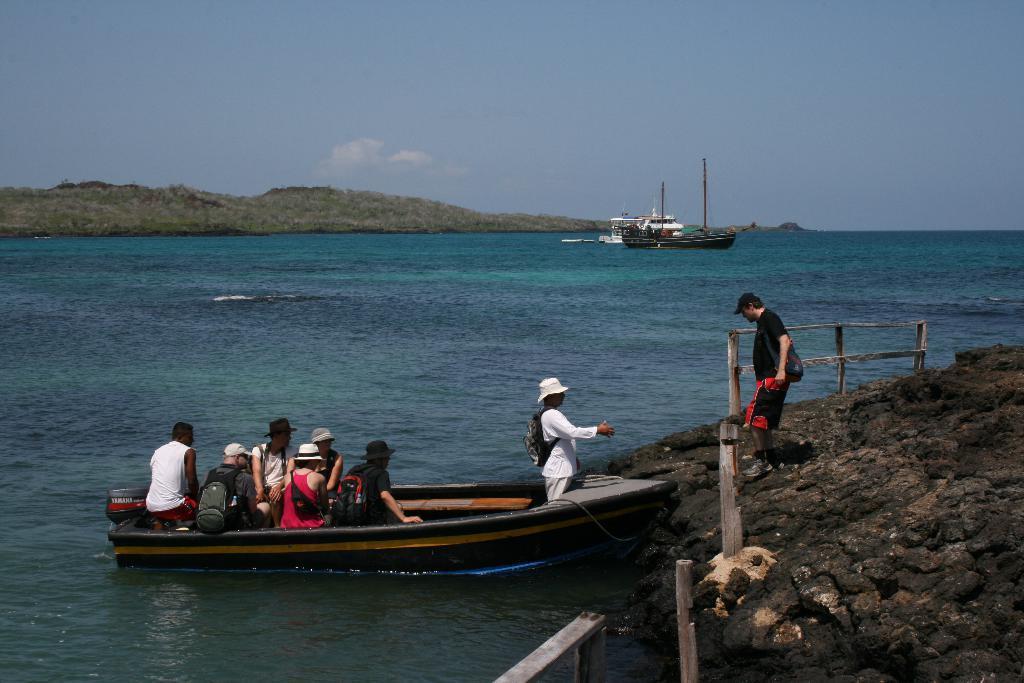Describe this image in one or two sentences. Few people are sitting in a boat and these two people wore bags. We can see ships and boat above the water. Background we can see grass and sky. 